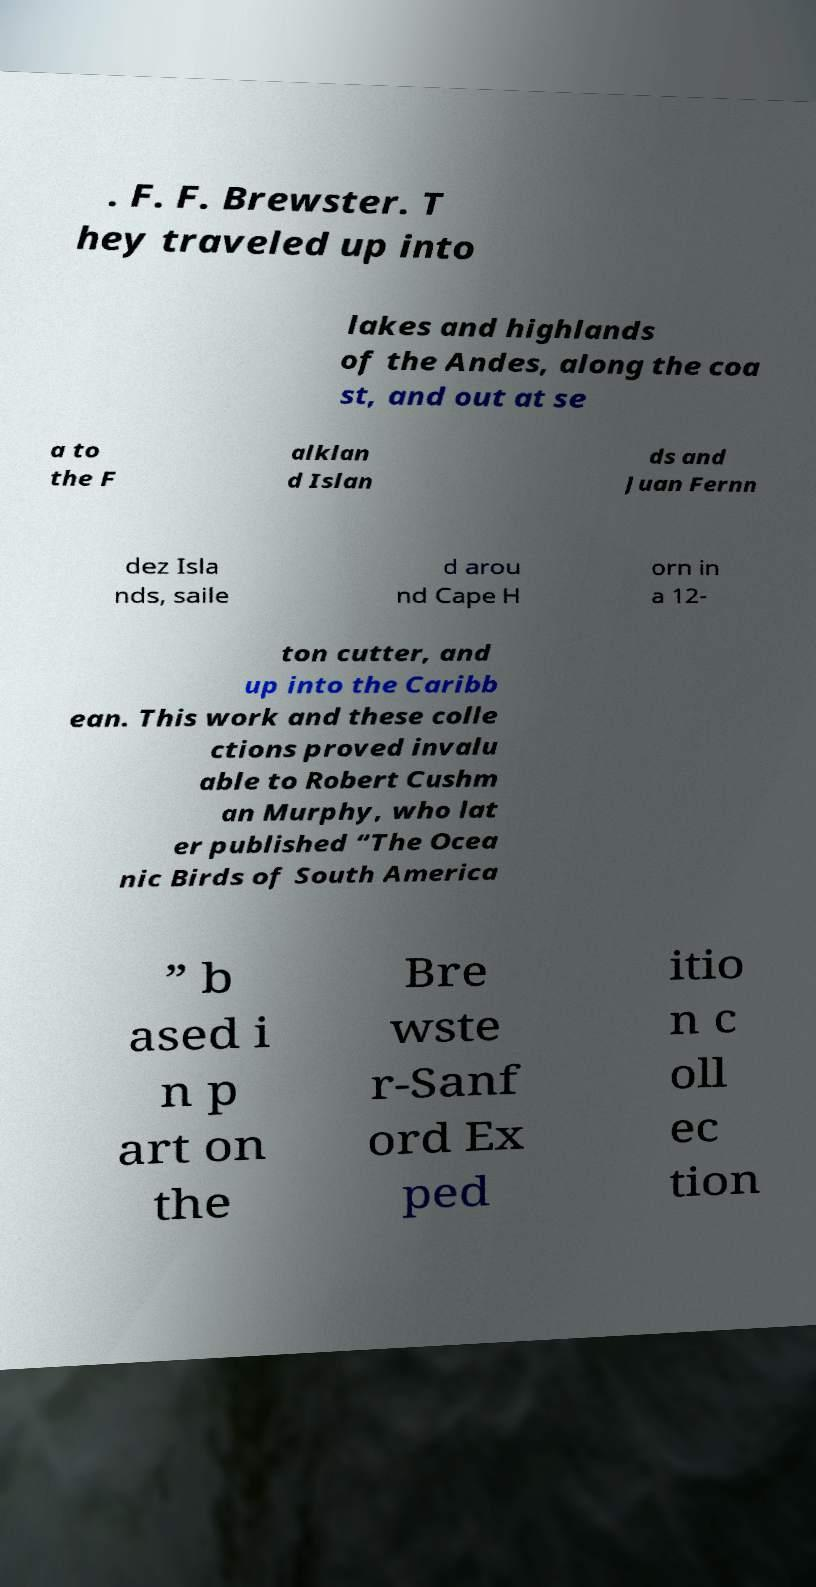Could you assist in decoding the text presented in this image and type it out clearly? . F. F. Brewster. T hey traveled up into lakes and highlands of the Andes, along the coa st, and out at se a to the F alklan d Islan ds and Juan Fernn dez Isla nds, saile d arou nd Cape H orn in a 12- ton cutter, and up into the Caribb ean. This work and these colle ctions proved invalu able to Robert Cushm an Murphy, who lat er published “The Ocea nic Birds of South America ” b ased i n p art on the Bre wste r-Sanf ord Ex ped itio n c oll ec tion 